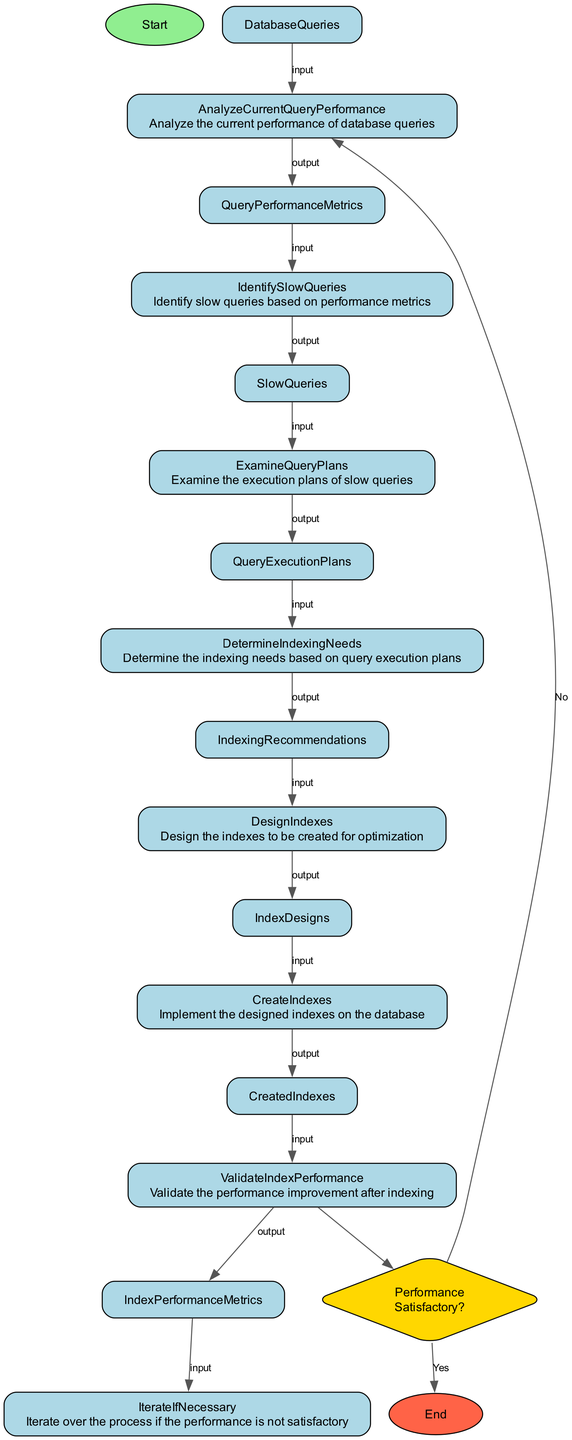What's the first step in the diagram? The first step in the diagram is labeled as "Start," which indicates the beginning of the database indexing process.
Answer: Start How many main activities are depicted in this diagram? The diagram shows a total of eight main activities, excluding the Start and End nodes. These activities include analyzing query performance, identifying slow queries, examining query plans, determining indexing needs, designing indexes, creating indexes, and validating index performance.
Answer: Eight What is the output of the "CreateIndexes" node? The "CreateIndexes" node has an output labeled "CreatedIndexes," indicating that this step results in the creation of the indexes as designed in preceding steps.
Answer: CreatedIndexes Which step follows "ValidateIndexPerformance" if the performance is not satisfactory? If the performance is not satisfactory, the next step is to "AnalyzeCurrentQueryPerformance," which involves taking another look at the query performance metrics to identify further improvements needed.
Answer: AnalyzeCurrentQueryPerformance What decision point is present in the diagram? The decision point present in the diagram is "Performance Satisfactory?", which evaluates whether the performance after validation meets the expectations or requires further analysis.
Answer: Performance Satisfactory? What input is required for the "DetermineIndexingNeeds" activity? The input required for the "DetermineIndexingNeeds" activity is "QueryExecutionPlans," which contains the execution plans of the identified slow queries that inform the indexing recommendations.
Answer: QueryExecutionPlans What happens if the performance is satisfactory? If the performance is satisfactory, the process leads to the "End" node, indicating that no further steps are needed and the indexing implementation is complete.
Answer: End How does the "IdentifySlowQueries" activity receive its input? The "IdentifySlowQueries" activity receives its input from the "QueryPerformanceMetrics," which summarize the performance data of the database queries and allow for the identification of those that are slow.
Answer: QueryPerformanceMetrics 